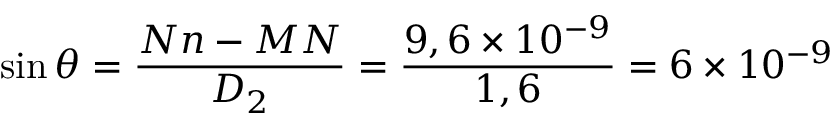<formula> <loc_0><loc_0><loc_500><loc_500>\sin \theta = \frac { N n - M N } { D _ { 2 } } = \frac { 9 , 6 \times 1 0 ^ { - 9 } } { 1 , 6 } = 6 \times 1 0 ^ { - 9 }</formula> 